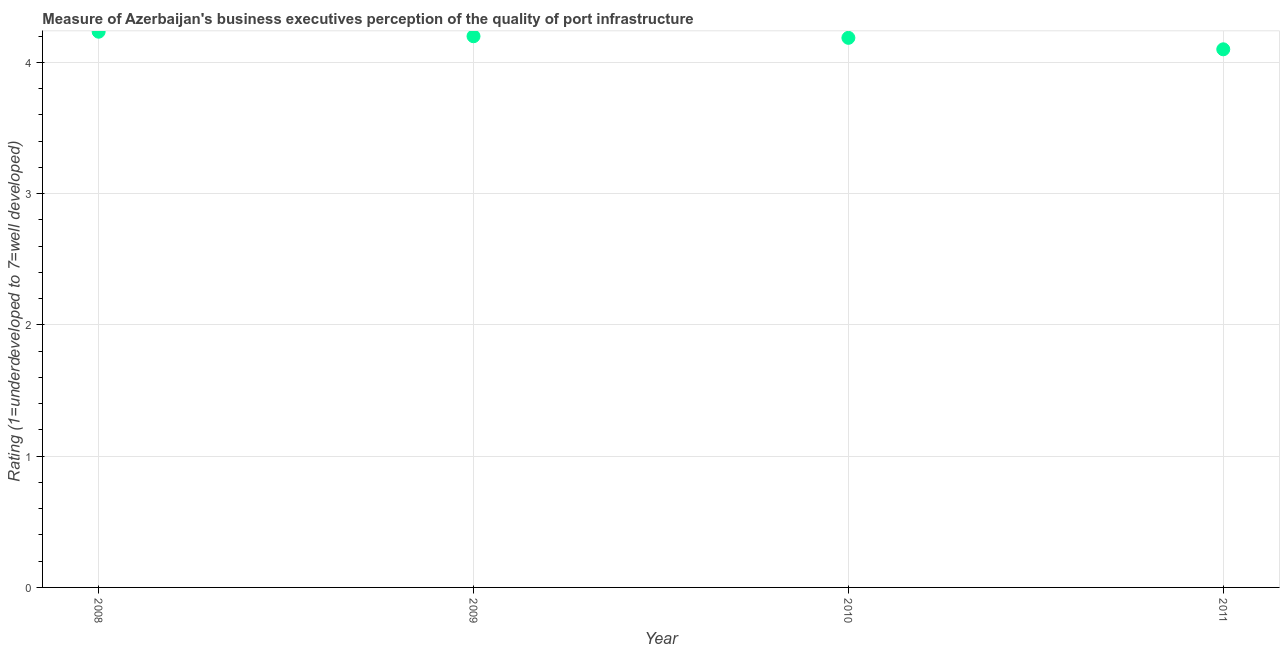What is the rating measuring quality of port infrastructure in 2008?
Give a very brief answer. 4.23. Across all years, what is the maximum rating measuring quality of port infrastructure?
Provide a short and direct response. 4.23. Across all years, what is the minimum rating measuring quality of port infrastructure?
Provide a succinct answer. 4.1. In which year was the rating measuring quality of port infrastructure maximum?
Offer a very short reply. 2008. What is the sum of the rating measuring quality of port infrastructure?
Offer a very short reply. 16.72. What is the difference between the rating measuring quality of port infrastructure in 2008 and 2010?
Keep it short and to the point. 0.05. What is the average rating measuring quality of port infrastructure per year?
Your response must be concise. 4.18. What is the median rating measuring quality of port infrastructure?
Offer a terse response. 4.19. In how many years, is the rating measuring quality of port infrastructure greater than 2.6 ?
Offer a very short reply. 4. Do a majority of the years between 2009 and 2008 (inclusive) have rating measuring quality of port infrastructure greater than 0.2 ?
Provide a short and direct response. No. What is the ratio of the rating measuring quality of port infrastructure in 2008 to that in 2011?
Provide a short and direct response. 1.03. Is the rating measuring quality of port infrastructure in 2008 less than that in 2009?
Ensure brevity in your answer.  No. Is the difference between the rating measuring quality of port infrastructure in 2008 and 2009 greater than the difference between any two years?
Offer a terse response. No. What is the difference between the highest and the second highest rating measuring quality of port infrastructure?
Keep it short and to the point. 0.03. What is the difference between the highest and the lowest rating measuring quality of port infrastructure?
Provide a short and direct response. 0.13. In how many years, is the rating measuring quality of port infrastructure greater than the average rating measuring quality of port infrastructure taken over all years?
Provide a short and direct response. 3. How many years are there in the graph?
Offer a terse response. 4. Are the values on the major ticks of Y-axis written in scientific E-notation?
Ensure brevity in your answer.  No. What is the title of the graph?
Offer a very short reply. Measure of Azerbaijan's business executives perception of the quality of port infrastructure. What is the label or title of the Y-axis?
Your response must be concise. Rating (1=underdeveloped to 7=well developed) . What is the Rating (1=underdeveloped to 7=well developed)  in 2008?
Keep it short and to the point. 4.23. What is the Rating (1=underdeveloped to 7=well developed)  in 2009?
Your response must be concise. 4.2. What is the Rating (1=underdeveloped to 7=well developed)  in 2010?
Keep it short and to the point. 4.19. What is the Rating (1=underdeveloped to 7=well developed)  in 2011?
Ensure brevity in your answer.  4.1. What is the difference between the Rating (1=underdeveloped to 7=well developed)  in 2008 and 2009?
Provide a short and direct response. 0.03. What is the difference between the Rating (1=underdeveloped to 7=well developed)  in 2008 and 2010?
Your answer should be very brief. 0.05. What is the difference between the Rating (1=underdeveloped to 7=well developed)  in 2008 and 2011?
Offer a very short reply. 0.13. What is the difference between the Rating (1=underdeveloped to 7=well developed)  in 2009 and 2010?
Your answer should be compact. 0.01. What is the difference between the Rating (1=underdeveloped to 7=well developed)  in 2009 and 2011?
Your response must be concise. 0.1. What is the difference between the Rating (1=underdeveloped to 7=well developed)  in 2010 and 2011?
Ensure brevity in your answer.  0.09. What is the ratio of the Rating (1=underdeveloped to 7=well developed)  in 2008 to that in 2009?
Provide a succinct answer. 1.01. What is the ratio of the Rating (1=underdeveloped to 7=well developed)  in 2008 to that in 2011?
Provide a succinct answer. 1.03. What is the ratio of the Rating (1=underdeveloped to 7=well developed)  in 2009 to that in 2011?
Your answer should be very brief. 1.02. What is the ratio of the Rating (1=underdeveloped to 7=well developed)  in 2010 to that in 2011?
Your response must be concise. 1.02. 